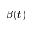<formula> <loc_0><loc_0><loc_500><loc_500>\beta ( t )</formula> 